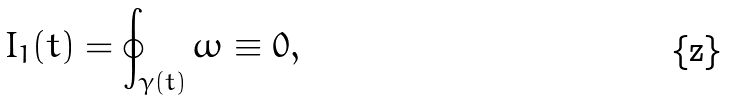<formula> <loc_0><loc_0><loc_500><loc_500>I _ { 1 } ( t ) = \oint _ { \gamma ( t ) } \omega \equiv 0 ,</formula> 